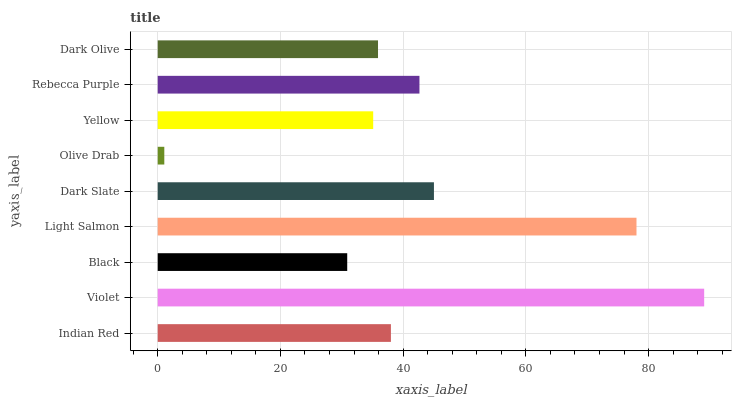Is Olive Drab the minimum?
Answer yes or no. Yes. Is Violet the maximum?
Answer yes or no. Yes. Is Black the minimum?
Answer yes or no. No. Is Black the maximum?
Answer yes or no. No. Is Violet greater than Black?
Answer yes or no. Yes. Is Black less than Violet?
Answer yes or no. Yes. Is Black greater than Violet?
Answer yes or no. No. Is Violet less than Black?
Answer yes or no. No. Is Indian Red the high median?
Answer yes or no. Yes. Is Indian Red the low median?
Answer yes or no. Yes. Is Rebecca Purple the high median?
Answer yes or no. No. Is Olive Drab the low median?
Answer yes or no. No. 